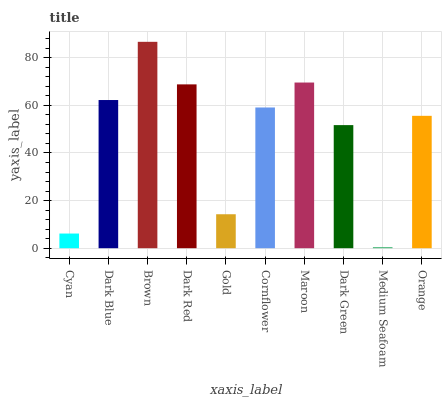Is Dark Blue the minimum?
Answer yes or no. No. Is Dark Blue the maximum?
Answer yes or no. No. Is Dark Blue greater than Cyan?
Answer yes or no. Yes. Is Cyan less than Dark Blue?
Answer yes or no. Yes. Is Cyan greater than Dark Blue?
Answer yes or no. No. Is Dark Blue less than Cyan?
Answer yes or no. No. Is Cornflower the high median?
Answer yes or no. Yes. Is Orange the low median?
Answer yes or no. Yes. Is Dark Red the high median?
Answer yes or no. No. Is Dark Red the low median?
Answer yes or no. No. 